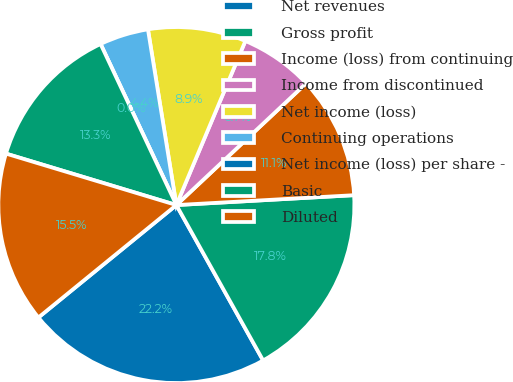Convert chart to OTSL. <chart><loc_0><loc_0><loc_500><loc_500><pie_chart><fcel>Net revenues<fcel>Gross profit<fcel>Income (loss) from continuing<fcel>Income from discontinued<fcel>Net income (loss)<fcel>Continuing operations<fcel>Net income (loss) per share -<fcel>Basic<fcel>Diluted<nl><fcel>22.22%<fcel>17.78%<fcel>11.11%<fcel>6.67%<fcel>8.89%<fcel>4.45%<fcel>0.0%<fcel>13.33%<fcel>15.55%<nl></chart> 